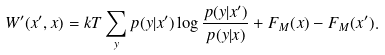Convert formula to latex. <formula><loc_0><loc_0><loc_500><loc_500>W ^ { \prime } ( x ^ { \prime } , x ) = k T \sum _ { y } p ( y | x ^ { \prime } ) \log \frac { p ( y | x ^ { \prime } ) } { p ( y | x ) } + F _ { M } ( x ) - F _ { M } ( x ^ { \prime } ) .</formula> 